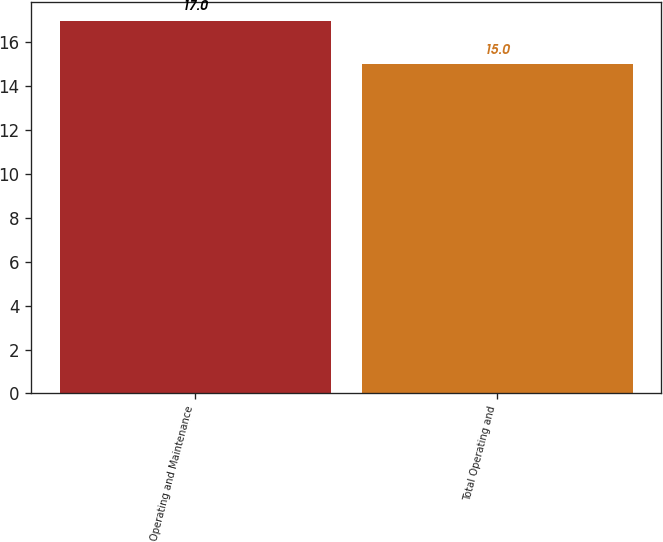Convert chart. <chart><loc_0><loc_0><loc_500><loc_500><bar_chart><fcel>Operating and Maintenance<fcel>Total Operating and<nl><fcel>17<fcel>15<nl></chart> 